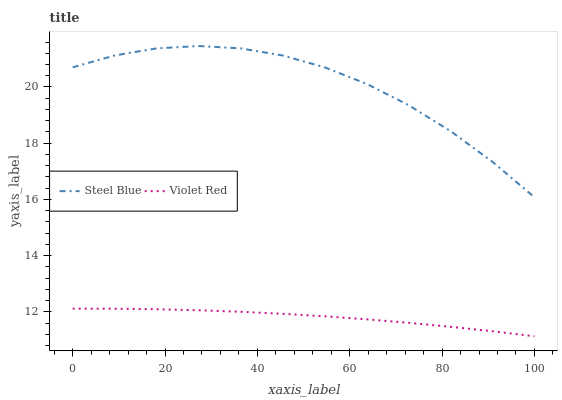Does Violet Red have the minimum area under the curve?
Answer yes or no. Yes. Does Steel Blue have the maximum area under the curve?
Answer yes or no. Yes. Does Steel Blue have the minimum area under the curve?
Answer yes or no. No. Is Violet Red the smoothest?
Answer yes or no. Yes. Is Steel Blue the roughest?
Answer yes or no. Yes. Is Steel Blue the smoothest?
Answer yes or no. No. Does Violet Red have the lowest value?
Answer yes or no. Yes. Does Steel Blue have the lowest value?
Answer yes or no. No. Does Steel Blue have the highest value?
Answer yes or no. Yes. Is Violet Red less than Steel Blue?
Answer yes or no. Yes. Is Steel Blue greater than Violet Red?
Answer yes or no. Yes. Does Violet Red intersect Steel Blue?
Answer yes or no. No. 